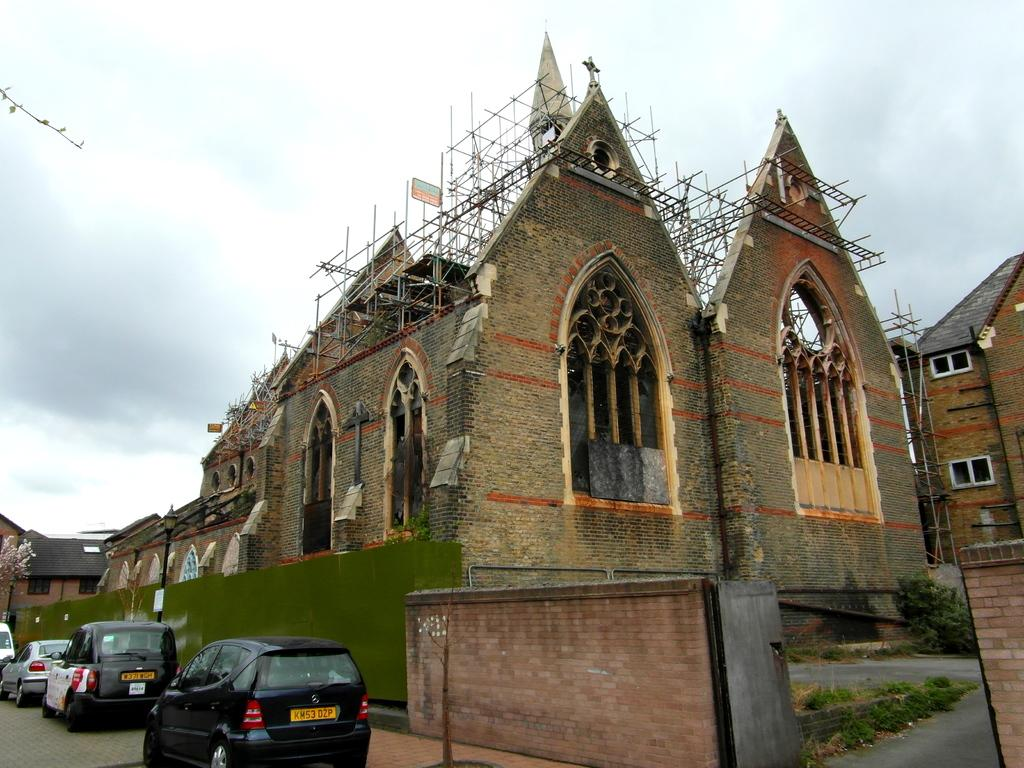What is the main structure in the center of the image? There is a church in the center of the image. What other structures can be seen in the image? There are buildings in the image. What type of transportation is visible at the bottom of the image? Vehicles are present at the bottom of the image. What object is present in the image that might be used for displaying signs or advertisements? There is a pole in the image. What is visible at the top of the image? The sky is visible at the top of the image. What color is the crayon used to draw the church in the image? There is no crayon present in the image; it is a photograph or illustration of a real church. What type of skin condition can be seen on the people in the image? There are no people visible in the image, only buildings, vehicles, and a pole. 